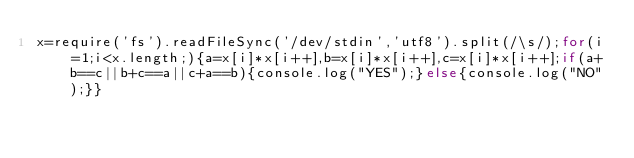<code> <loc_0><loc_0><loc_500><loc_500><_JavaScript_>x=require('fs').readFileSync('/dev/stdin','utf8').split(/\s/);for(i=1;i<x.length;){a=x[i]*x[i++],b=x[i]*x[i++],c=x[i]*x[i++];if(a+b==c||b+c==a||c+a==b){console.log("YES");}else{console.log("NO");}}</code> 